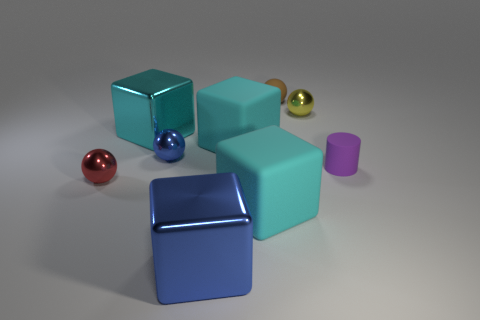Can you describe the positioning of the objects relative to each other? Certainly! In the image, there is a large teal cube positioned prominently in the center. To its right, there is a smaller blue cube with a glossy finish. In front of these, a tiny purple cylinder sits closely to the left of the large cube. A blue block lies behind the small blue cube, partially obscured. Finally, to the far right, there are three spheres of varying colors and sizes: a small red one, a medium-sized green one, and a large gold one. 